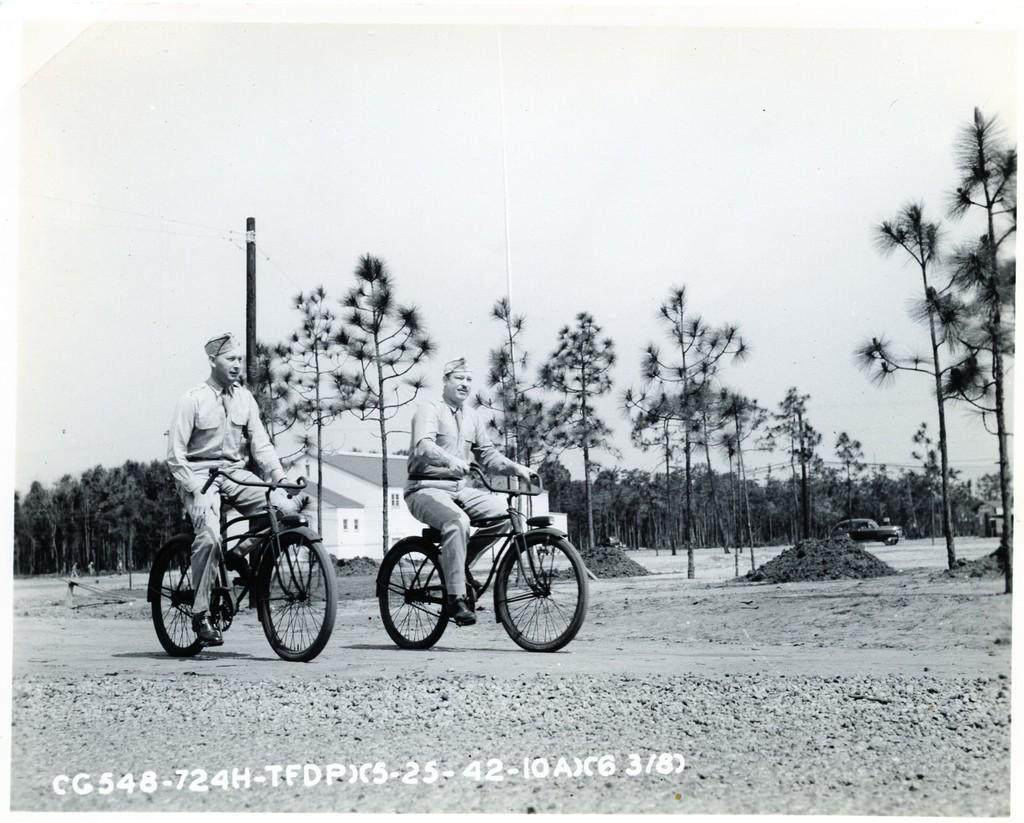How many people are in the image? There are two people in the image. What are the people doing in the image? The people are cycling their cycles. What can be seen in the background of the image? There are trees, a pole, and a building visible in the background of the image. What is the person's desire to step on the ray in the image? There is no mention of a ray or any desire to step on it in the image. 